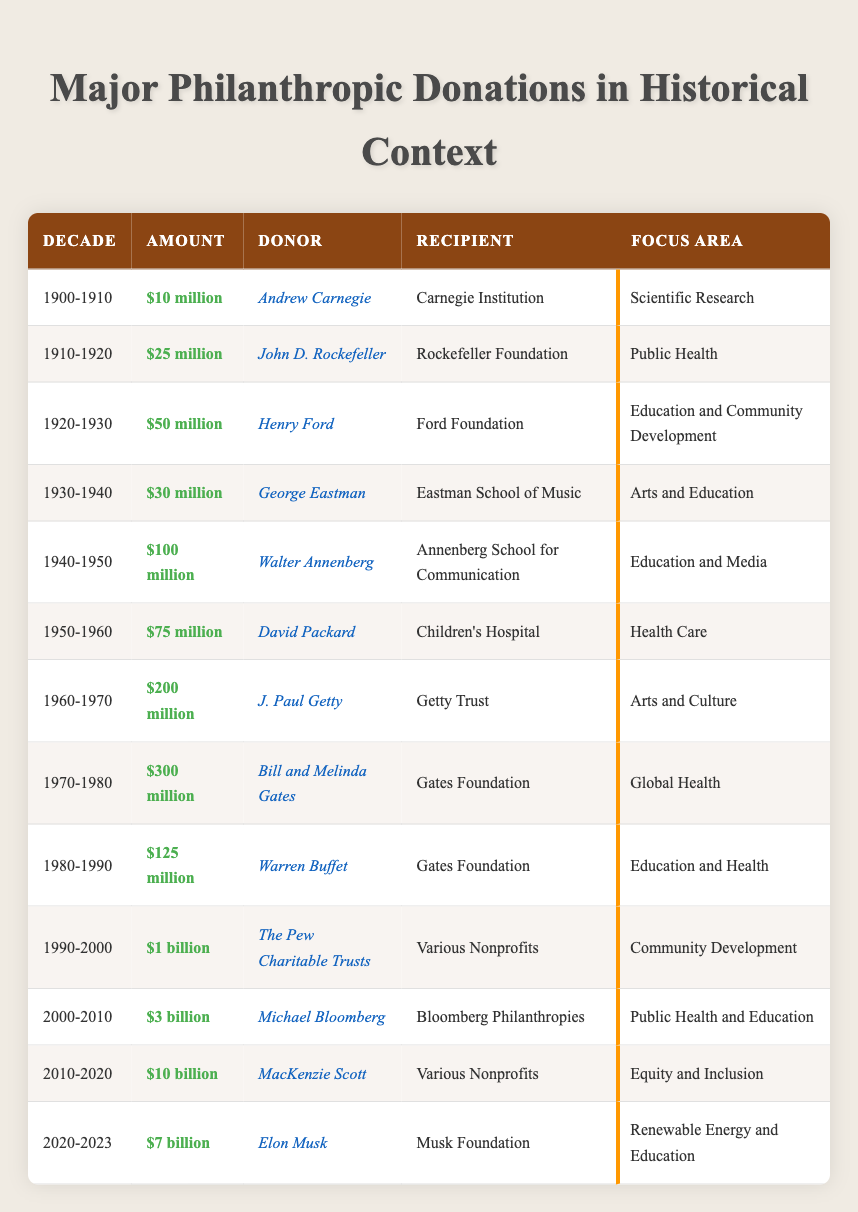What was the largest philanthropic donation made in the 2000-2010 decade? The 2000-2010 decade saw a donation of $3 billion by Michael Bloomberg to Bloomberg Philanthropies. This is the largest amount listed for that decade compared to others.
Answer: $3 billion Who donated to the Ford Foundation in the 1920-1930 decade? The donation to the Ford Foundation in the 1920-1930 decade was made by Henry Ford. This is directly stated under the respective row for that decade.
Answer: Henry Ford Which focus area received the highest total donations from 1960 to 1970? In the 1960-1970 decade, arts and culture received contributions from J. Paul Getty, totaling $200 million. This amount is larger compared to other focus areas during that time.
Answer: Arts and Culture Was the donation made by Bill and Melinda Gates in the 1970-1980 decade larger than $200 million? The donation made by Bill and Melinda Gates in the 1970-1980 decade was $300 million, which is indeed larger than $200 million.
Answer: Yes What is the total amount donated to health-related causes in the table? The health-related donations consist of $75 million to Children's Hospital (1950-1960) and $300 million to Global Health by Bill and Melinda Gates (1970-1980). Adding these amounts together gives $375 million.
Answer: $375 million How much did MacKenzie Scott donate in the 2010-2020 decade compared to Elon Musk's donation in 2020-2023? MacKenzie Scott donated $10 billion in the 2010-2020 decade, while Elon Musk donated $7 billion in the 2020-2023 decade. Thus, Scott's donation is larger.
Answer: $10 billion vs $7 billion Which donor made a contribution to public health? The contributors to public health include John D. Rockefeller, who donated $25 million to the Rockefeller Foundation (1910-1920), and Michael Bloomberg, who donated $3 billion to public health and education in the 2000-2010 decade.
Answer: John D. Rockefeller and Michael Bloomberg How much was donated to various nonprofits in the 1990-2000 decade? The amount donated to various nonprofits in the 1990-2000 decade was significant, totaling $1 billion from The Pew Charitable Trusts. This value is clearly indicated under the respective decade.
Answer: $1 billion Which decade saw a donation of $100 million, and who was the donor? The 1940-1950 decade had a donation of $100 million, made by Walter Annenberg to the Annenberg School for Communication, as indicated in the row for that decade.
Answer: 1940-1950, Walter Annenberg What is the average amount donated in the 1970-1980 and 1980-1990 decades? The donations were $300 million (1970-1980) from Bill and Melinda Gates and $125 million (1980-1990) from Warren Buffet. To find the average, add $300 million and $125 million to get $425 million, then divide by 2 to get $212.5 million.
Answer: $212.5 million What focus areas are represented in the donations made by Andrew Carnegie and George Eastman? Andrew Carnegie's focus area was scientific research, while George Eastman's focus area was arts and education. These can be checked directly from their respective rows.
Answer: Scientific Research and Arts and Education 